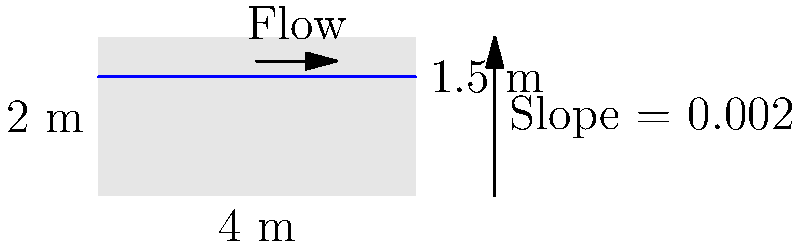As a mentor to aspiring young scientists, you're teaching about hydraulics in open channels. Consider a rectangular open channel with a width of 4 m and a depth of 2 m. The water depth is 1.5 m, and the channel has a slope of 0.002. Using Manning's equation with a roughness coefficient of 0.013, calculate the flow rate in the channel in $\text{m}^3/\text{s}$. To calculate the flow rate in an open channel, we'll use Manning's equation:

$$Q = \frac{1}{n} A R^{2/3} S^{1/2}$$

Where:
$Q$ = flow rate ($\text{m}^3/\text{s}$)
$n$ = Manning's roughness coefficient (given as 0.013)
$A$ = cross-sectional area of flow ($\text{m}^2$)
$R$ = hydraulic radius (m)
$S$ = channel slope (given as 0.002)

Step 1: Calculate the cross-sectional area (A)
$A = \text{width} \times \text{water depth} = 4 \text{ m} \times 1.5 \text{ m} = 6 \text{ m}^2$

Step 2: Calculate the wetted perimeter (P)
$P = \text{width} + 2 \times \text{water depth} = 4 \text{ m} + 2 \times 1.5 \text{ m} = 7 \text{ m}$

Step 3: Calculate the hydraulic radius (R)
$R = \frac{A}{P} = \frac{6 \text{ m}^2}{7 \text{ m}} = 0.857 \text{ m}$

Step 4: Apply Manning's equation
$$Q = \frac{1}{0.013} \times 6 \times 0.857^{2/3} \times 0.002^{1/2}$$

Step 5: Calculate the result
$$Q = 76.92 \times 0.9055 \times 0.0447 = 3.11 \text{ m}^3/\text{s}$$
Answer: $3.11 \text{ m}^3/\text{s}$ 